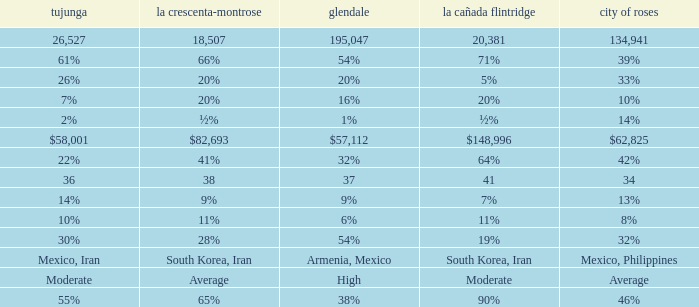What is the figure for La Canada Flintridge when Pasadena is 34? 41.0. 